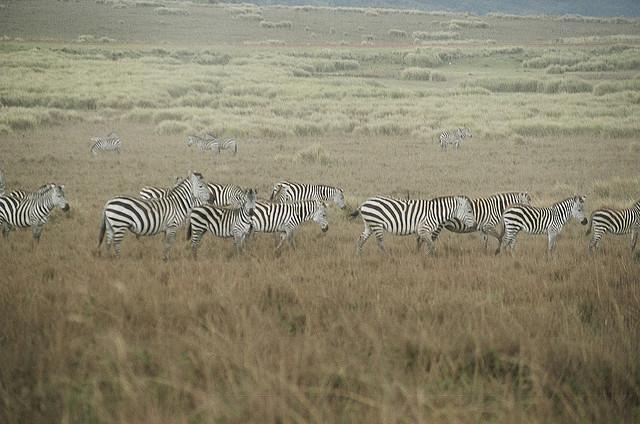How many zebras can you see?
Give a very brief answer. 7. 